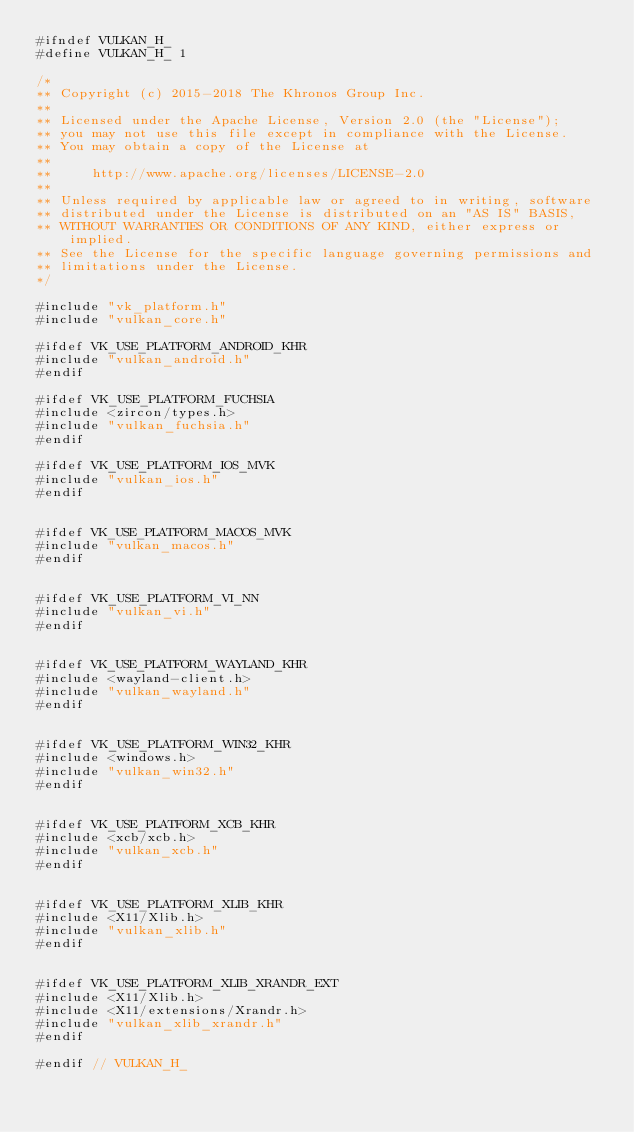Convert code to text. <code><loc_0><loc_0><loc_500><loc_500><_C_>#ifndef VULKAN_H_
#define VULKAN_H_ 1

/*
** Copyright (c) 2015-2018 The Khronos Group Inc.
**
** Licensed under the Apache License, Version 2.0 (the "License");
** you may not use this file except in compliance with the License.
** You may obtain a copy of the License at
**
**     http://www.apache.org/licenses/LICENSE-2.0
**
** Unless required by applicable law or agreed to in writing, software
** distributed under the License is distributed on an "AS IS" BASIS,
** WITHOUT WARRANTIES OR CONDITIONS OF ANY KIND, either express or implied.
** See the License for the specific language governing permissions and
** limitations under the License.
*/

#include "vk_platform.h"
#include "vulkan_core.h"

#ifdef VK_USE_PLATFORM_ANDROID_KHR
#include "vulkan_android.h"
#endif

#ifdef VK_USE_PLATFORM_FUCHSIA
#include <zircon/types.h>
#include "vulkan_fuchsia.h"
#endif

#ifdef VK_USE_PLATFORM_IOS_MVK
#include "vulkan_ios.h"
#endif


#ifdef VK_USE_PLATFORM_MACOS_MVK
#include "vulkan_macos.h"
#endif


#ifdef VK_USE_PLATFORM_VI_NN
#include "vulkan_vi.h"
#endif


#ifdef VK_USE_PLATFORM_WAYLAND_KHR
#include <wayland-client.h>
#include "vulkan_wayland.h"
#endif


#ifdef VK_USE_PLATFORM_WIN32_KHR
#include <windows.h>
#include "vulkan_win32.h"
#endif


#ifdef VK_USE_PLATFORM_XCB_KHR
#include <xcb/xcb.h>
#include "vulkan_xcb.h"
#endif


#ifdef VK_USE_PLATFORM_XLIB_KHR
#include <X11/Xlib.h>
#include "vulkan_xlib.h"
#endif


#ifdef VK_USE_PLATFORM_XLIB_XRANDR_EXT
#include <X11/Xlib.h>
#include <X11/extensions/Xrandr.h>
#include "vulkan_xlib_xrandr.h"
#endif

#endif // VULKAN_H_
</code> 